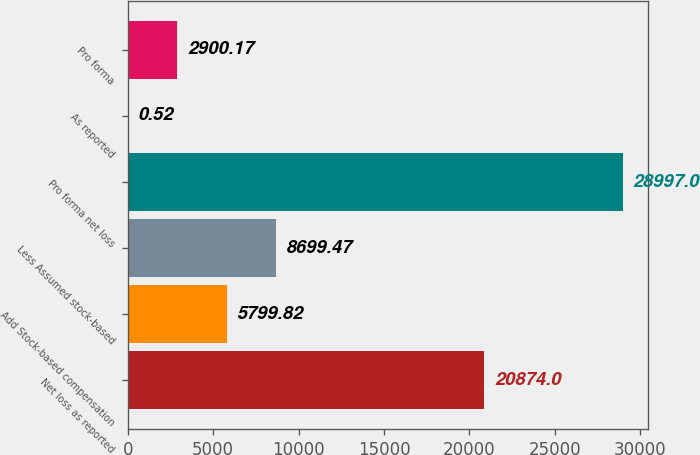Convert chart. <chart><loc_0><loc_0><loc_500><loc_500><bar_chart><fcel>Net loss as reported<fcel>Add Stock-based compensation<fcel>Less Assumed stock-based<fcel>Pro forma net loss<fcel>As reported<fcel>Pro forma<nl><fcel>20874<fcel>5799.82<fcel>8699.47<fcel>28997<fcel>0.52<fcel>2900.17<nl></chart> 